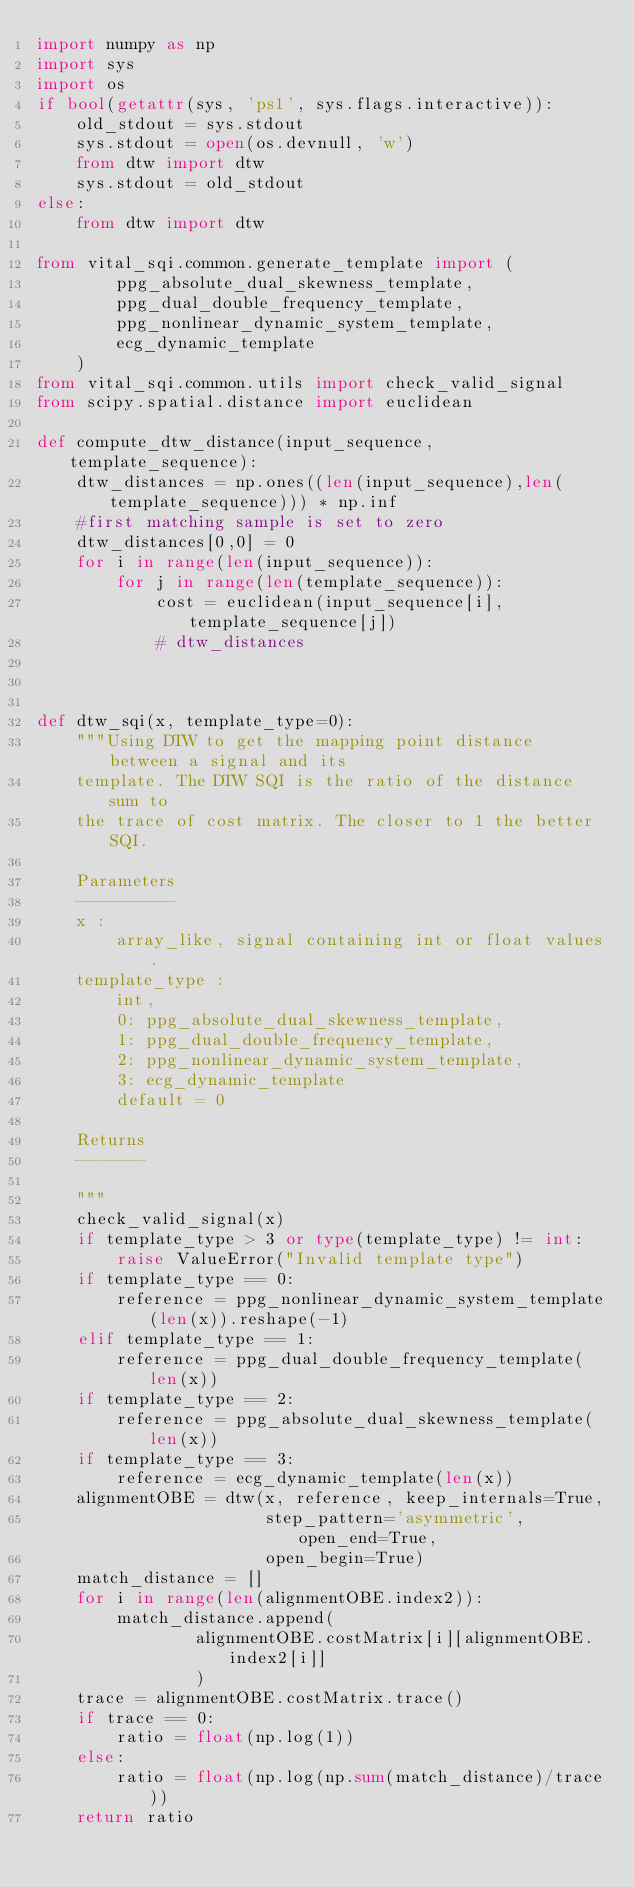<code> <loc_0><loc_0><loc_500><loc_500><_Python_>import numpy as np
import sys
import os
if bool(getattr(sys, 'ps1', sys.flags.interactive)):
    old_stdout = sys.stdout
    sys.stdout = open(os.devnull, 'w')
    from dtw import dtw
    sys.stdout = old_stdout
else:
    from dtw import dtw

from vital_sqi.common.generate_template import (
        ppg_absolute_dual_skewness_template,
        ppg_dual_double_frequency_template,
        ppg_nonlinear_dynamic_system_template,
        ecg_dynamic_template
    )
from vital_sqi.common.utils import check_valid_signal
from scipy.spatial.distance import euclidean

def compute_dtw_distance(input_sequence, template_sequence):
    dtw_distances = np.ones((len(input_sequence),len(template_sequence))) * np.inf
    #first matching sample is set to zero
    dtw_distances[0,0] = 0
    for i in range(len(input_sequence)):
        for j in range(len(template_sequence)):
            cost = euclidean(input_sequence[i],template_sequence[j])
            # dtw_distances



def dtw_sqi(x, template_type=0):
    """Using DTW to get the mapping point distance between a signal and its
    template. The DTW SQI is the ratio of the distance sum to
    the trace of cost matrix. The closer to 1 the better SQI.

    Parameters
    ----------
    x :
        array_like, signal containing int or float values.
    template_type :
        int,
        0: ppg_absolute_dual_skewness_template,
        1: ppg_dual_double_frequency_template,
        2: ppg_nonlinear_dynamic_system_template,
        3: ecg_dynamic_template
        default = 0

    Returns
    -------

    """
    check_valid_signal(x)
    if template_type > 3 or type(template_type) != int:
        raise ValueError("Invalid template type")
    if template_type == 0:
        reference = ppg_nonlinear_dynamic_system_template(len(x)).reshape(-1)
    elif template_type == 1:
        reference = ppg_dual_double_frequency_template(len(x))
    if template_type == 2:
        reference = ppg_absolute_dual_skewness_template(len(x))
    if template_type == 3:
        reference = ecg_dynamic_template(len(x))
    alignmentOBE = dtw(x, reference, keep_internals=True,
                       step_pattern='asymmetric', open_end=True,
                       open_begin=True)
    match_distance = []
    for i in range(len(alignmentOBE.index2)):
        match_distance.append(
                alignmentOBE.costMatrix[i][alignmentOBE.index2[i]]
                )
    trace = alignmentOBE.costMatrix.trace()
    if trace == 0:
        ratio = float(np.log(1))
    else:
        ratio = float(np.log(np.sum(match_distance)/trace))
    return ratio
</code> 